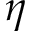<formula> <loc_0><loc_0><loc_500><loc_500>\eta</formula> 